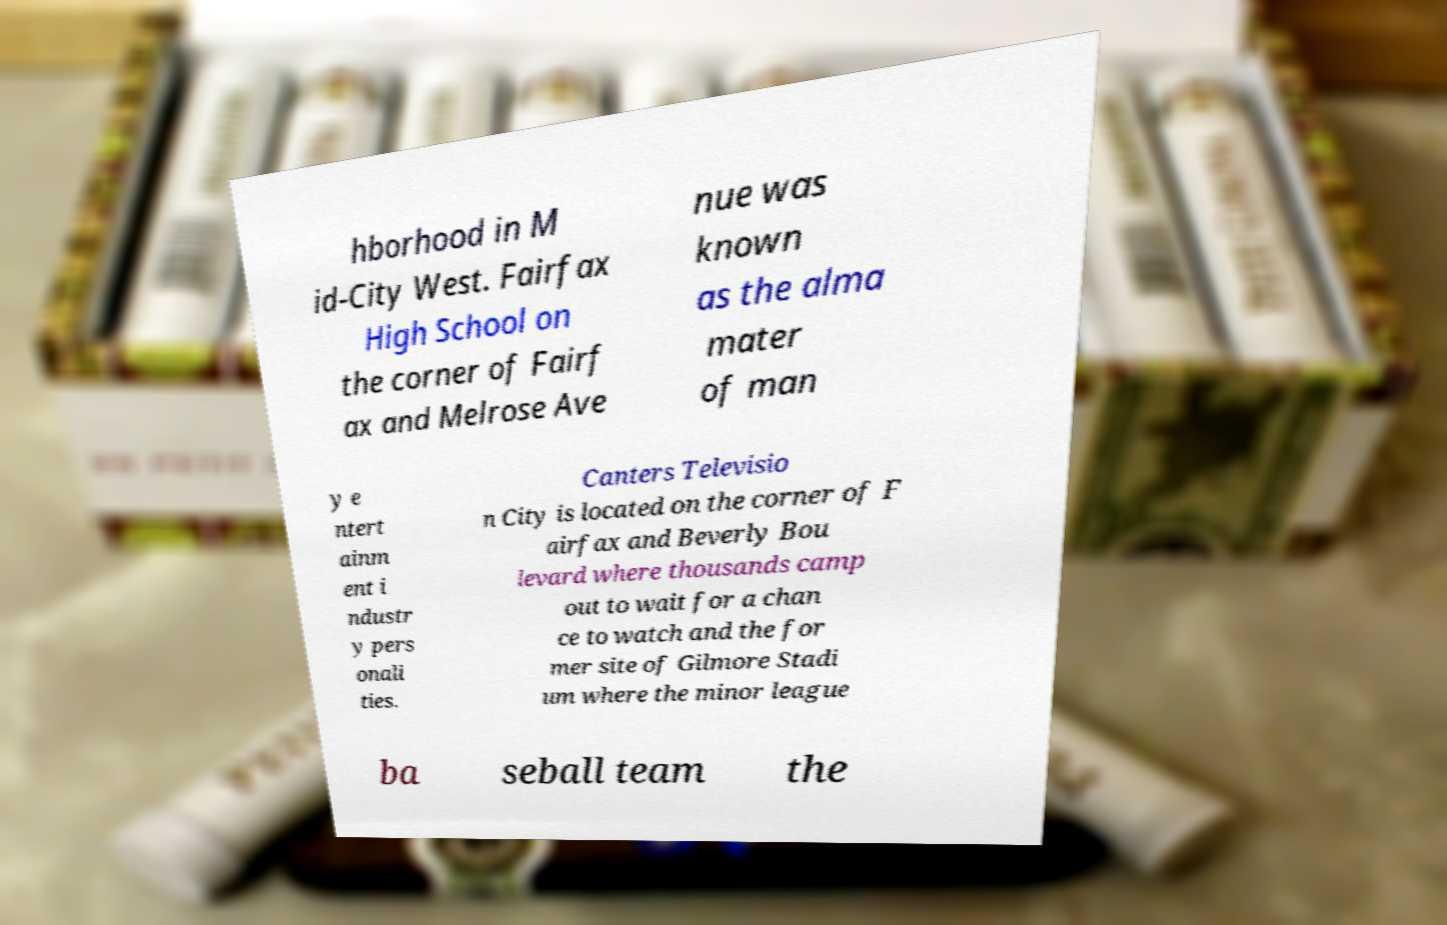Can you read and provide the text displayed in the image?This photo seems to have some interesting text. Can you extract and type it out for me? hborhood in M id-City West. Fairfax High School on the corner of Fairf ax and Melrose Ave nue was known as the alma mater of man y e ntert ainm ent i ndustr y pers onali ties. Canters Televisio n City is located on the corner of F airfax and Beverly Bou levard where thousands camp out to wait for a chan ce to watch and the for mer site of Gilmore Stadi um where the minor league ba seball team the 